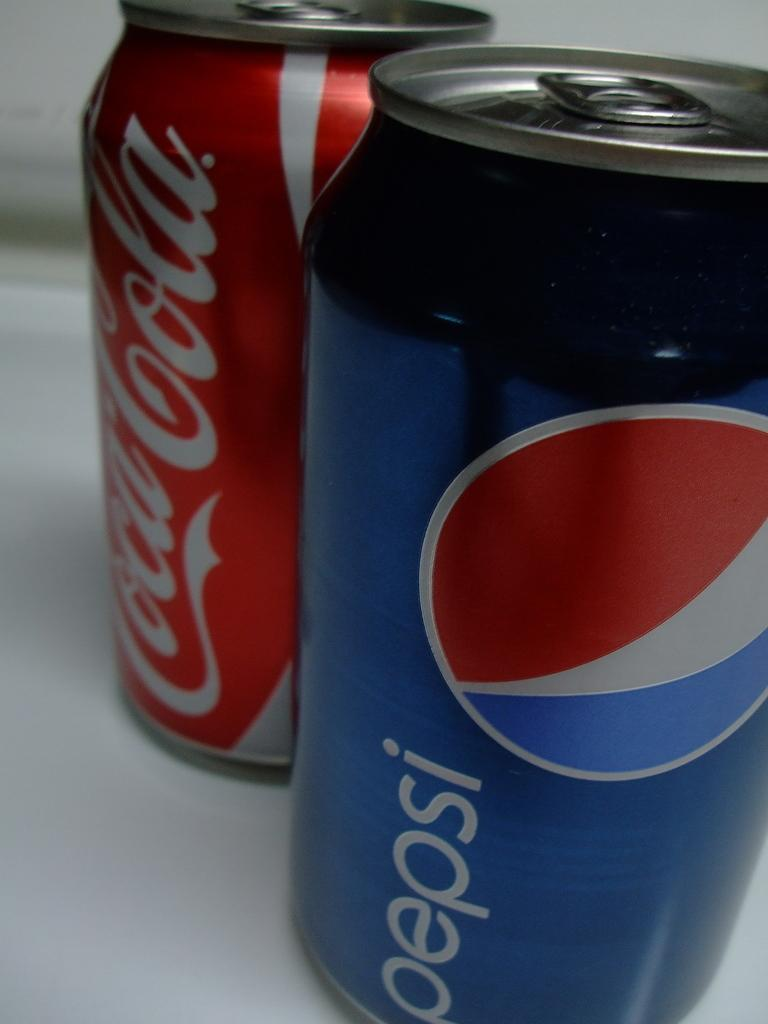<image>
Summarize the visual content of the image. A can of coca cola is behind a can of pepsi. 